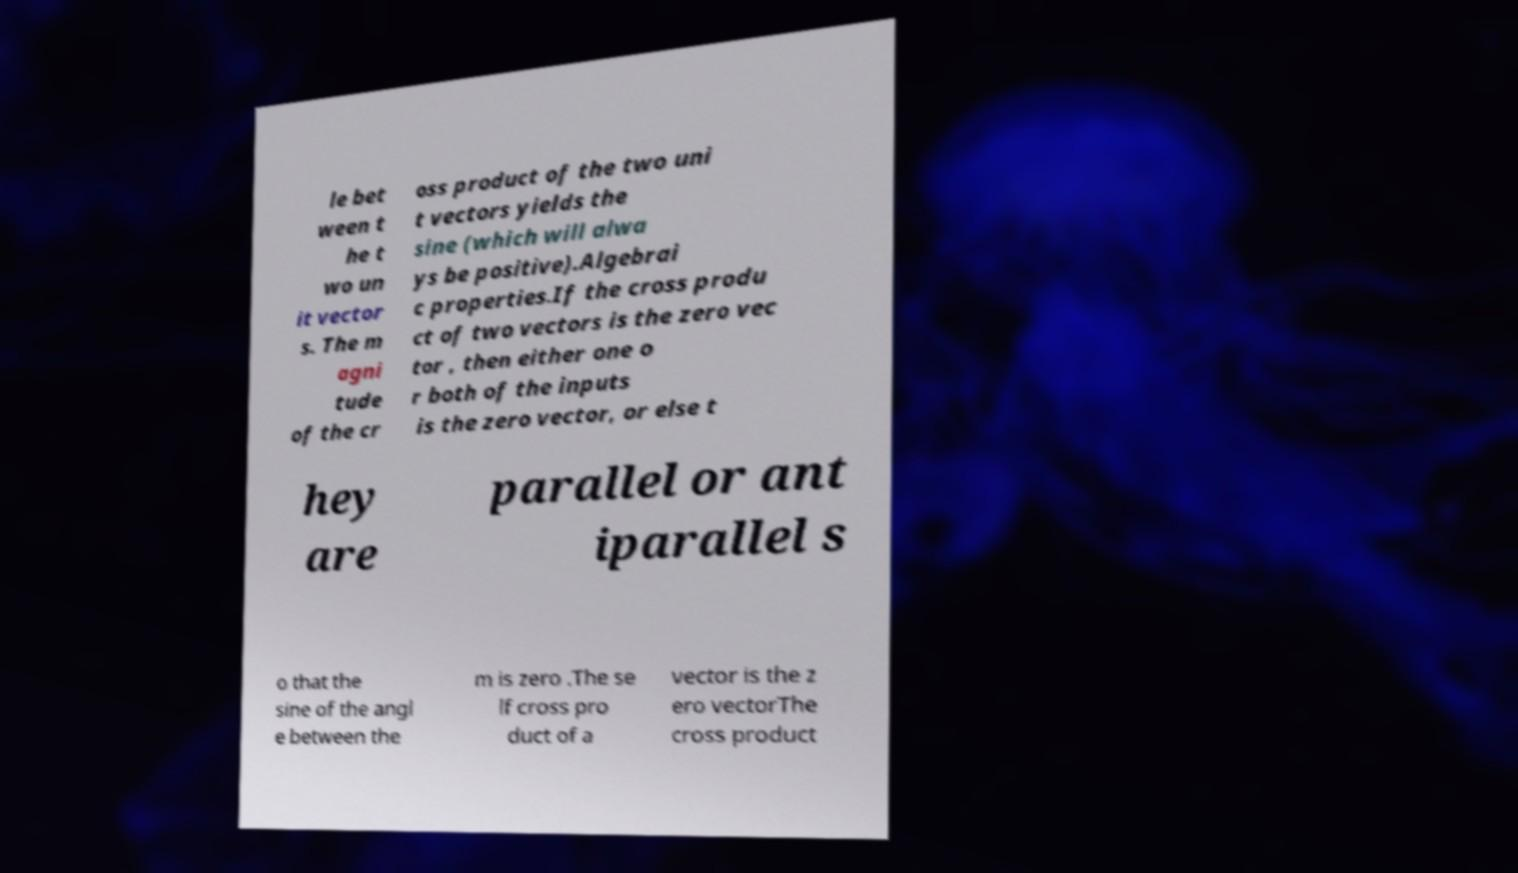I need the written content from this picture converted into text. Can you do that? le bet ween t he t wo un it vector s. The m agni tude of the cr oss product of the two uni t vectors yields the sine (which will alwa ys be positive).Algebrai c properties.If the cross produ ct of two vectors is the zero vec tor , then either one o r both of the inputs is the zero vector, or else t hey are parallel or ant iparallel s o that the sine of the angl e between the m is zero .The se lf cross pro duct of a vector is the z ero vectorThe cross product 